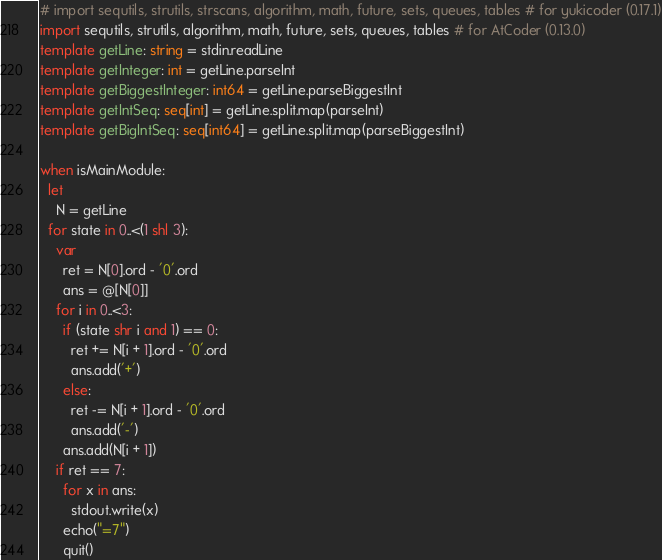Convert code to text. <code><loc_0><loc_0><loc_500><loc_500><_Nim_># import sequtils, strutils, strscans, algorithm, math, future, sets, queues, tables # for yukicoder (0.17.1)
import sequtils, strutils, algorithm, math, future, sets, queues, tables # for AtCoder (0.13.0)
template getLine: string = stdin.readLine
template getInteger: int = getLine.parseInt
template getBiggestInteger: int64 = getLine.parseBiggestInt
template getIntSeq: seq[int] = getLine.split.map(parseInt)
template getBigIntSeq: seq[int64] = getLine.split.map(parseBiggestInt)

when isMainModule:
  let
    N = getLine
  for state in 0..<(1 shl 3):
    var
      ret = N[0].ord - '0'.ord
      ans = @[N[0]]
    for i in 0..<3:
      if (state shr i and 1) == 0:
        ret += N[i + 1].ord - '0'.ord
        ans.add('+')
      else:
        ret -= N[i + 1].ord - '0'.ord
        ans.add('-')
      ans.add(N[i + 1])
    if ret == 7:
      for x in ans:
        stdout.write(x)
      echo("=7")
      quit()
</code> 